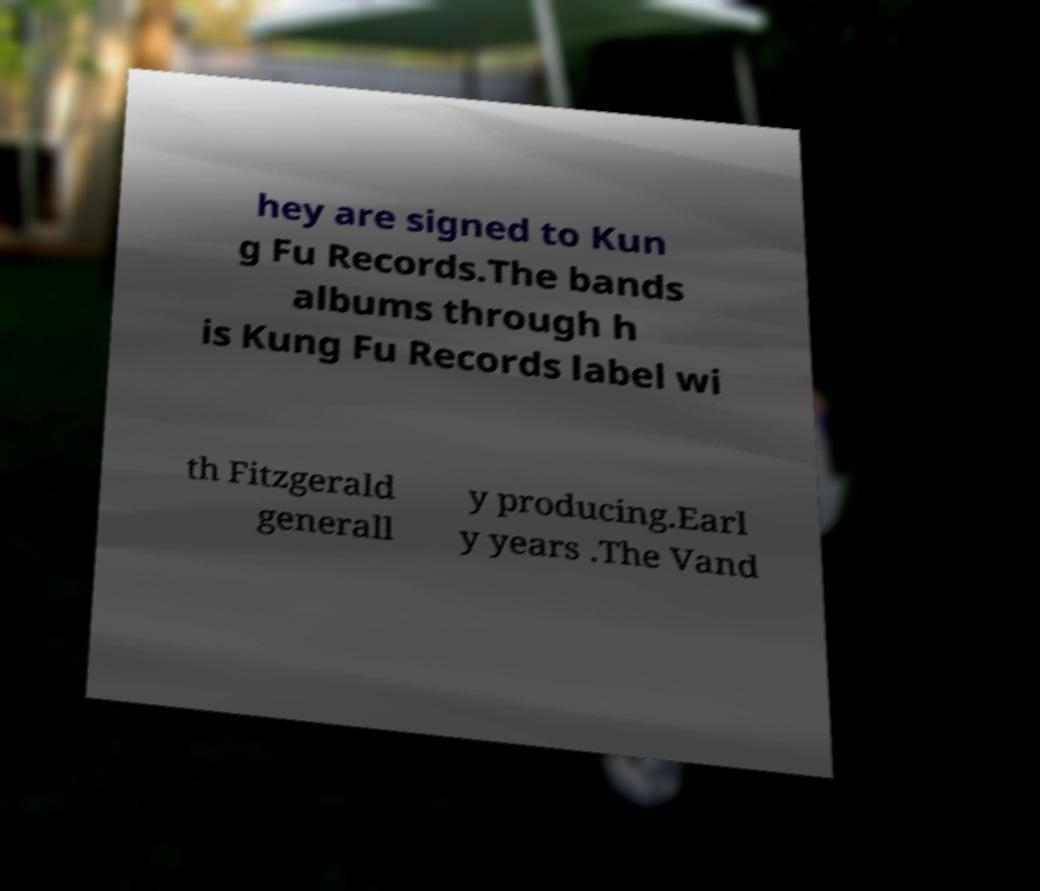I need the written content from this picture converted into text. Can you do that? hey are signed to Kun g Fu Records.The bands albums through h is Kung Fu Records label wi th Fitzgerald generall y producing.Earl y years .The Vand 